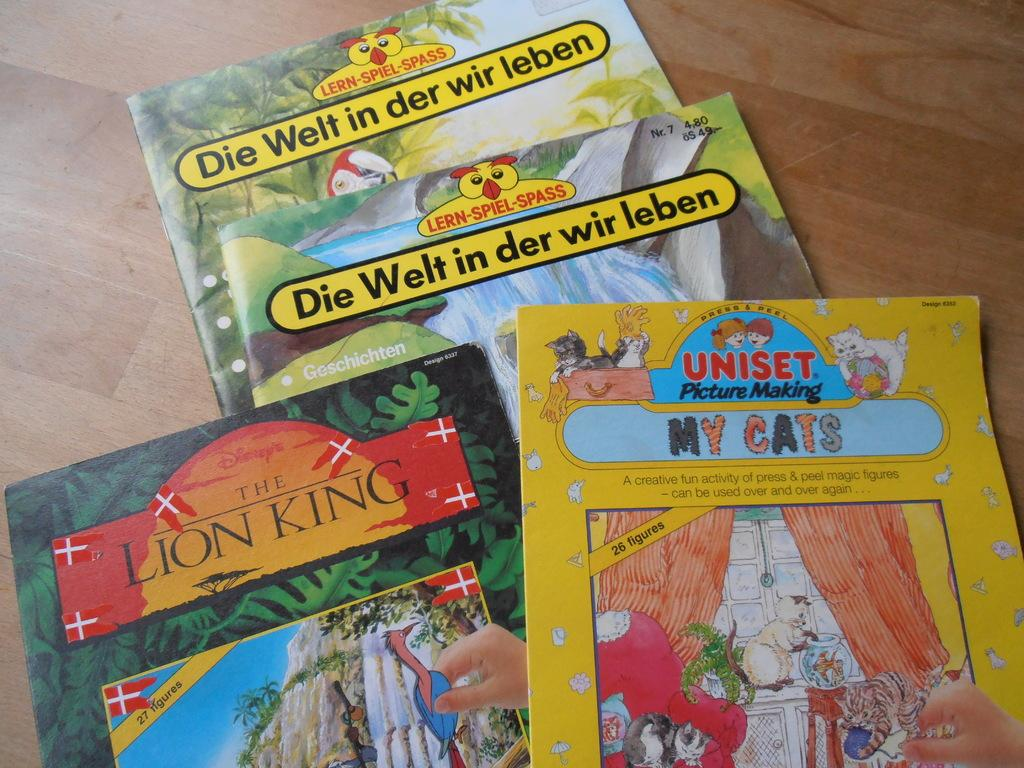<image>
Describe the image concisely. Four children's books including The Lion King on a table. 